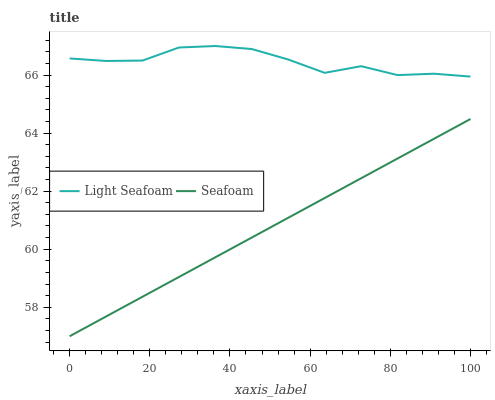Does Seafoam have the minimum area under the curve?
Answer yes or no. Yes. Does Light Seafoam have the maximum area under the curve?
Answer yes or no. Yes. Does Seafoam have the maximum area under the curve?
Answer yes or no. No. Is Seafoam the smoothest?
Answer yes or no. Yes. Is Light Seafoam the roughest?
Answer yes or no. Yes. Is Seafoam the roughest?
Answer yes or no. No. Does Seafoam have the lowest value?
Answer yes or no. Yes. Does Light Seafoam have the highest value?
Answer yes or no. Yes. Does Seafoam have the highest value?
Answer yes or no. No. Is Seafoam less than Light Seafoam?
Answer yes or no. Yes. Is Light Seafoam greater than Seafoam?
Answer yes or no. Yes. Does Seafoam intersect Light Seafoam?
Answer yes or no. No. 